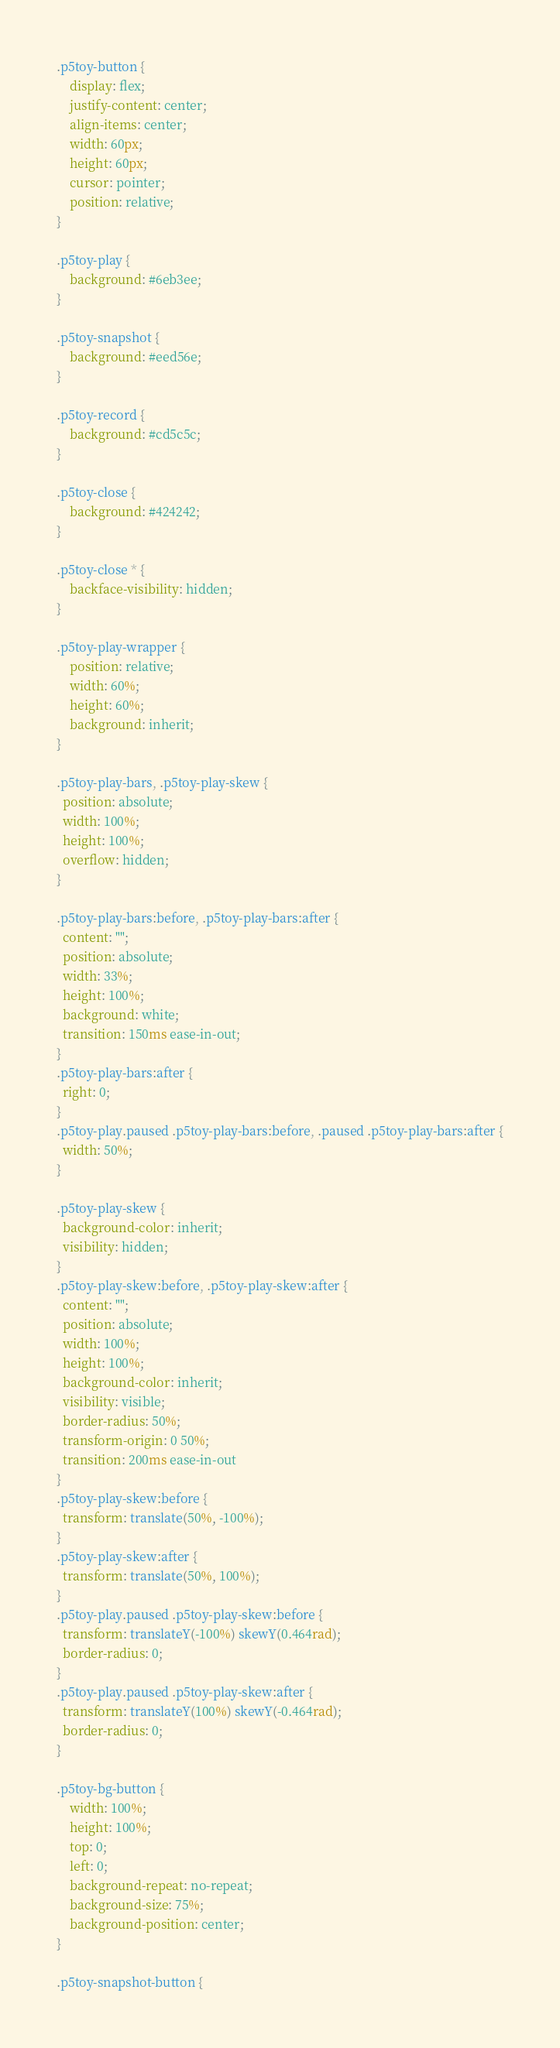Convert code to text. <code><loc_0><loc_0><loc_500><loc_500><_CSS_>
.p5toy-button {
	display: flex;
	justify-content: center;
	align-items: center;
	width: 60px;
	height: 60px;
	cursor: pointer;
	position: relative;
}

.p5toy-play {
	background: #6eb3ee;
}

.p5toy-snapshot {
	background: #eed56e;
}

.p5toy-record {
	background: #cd5c5c;
}

.p5toy-close {
	background: #424242;
}

.p5toy-close * {
	backface-visibility: hidden;
}

.p5toy-play-wrapper {
	position: relative;
	width: 60%;
	height: 60%;
	background: inherit;
}

.p5toy-play-bars, .p5toy-play-skew {
  position: absolute;
  width: 100%;
  height: 100%;
  overflow: hidden;
}

.p5toy-play-bars:before, .p5toy-play-bars:after {
  content: "";
  position: absolute;
  width: 33%;
  height: 100%;
  background: white;
  transition: 150ms ease-in-out;
}
.p5toy-play-bars:after {
  right: 0;
}
.p5toy-play.paused .p5toy-play-bars:before, .paused .p5toy-play-bars:after {
  width: 50%;
}

.p5toy-play-skew {
  background-color: inherit;
  visibility: hidden;
}
.p5toy-play-skew:before, .p5toy-play-skew:after {
  content: "";
  position: absolute;
  width: 100%;
  height: 100%;
  background-color: inherit;
  visibility: visible;
  border-radius: 50%;
  transform-origin: 0 50%;
  transition: 200ms ease-in-out
}
.p5toy-play-skew:before {
  transform: translate(50%, -100%);
}
.p5toy-play-skew:after {
  transform: translate(50%, 100%);
}
.p5toy-play.paused .p5toy-play-skew:before {
  transform: translateY(-100%) skewY(0.464rad);
  border-radius: 0;
}
.p5toy-play.paused .p5toy-play-skew:after {
  transform: translateY(100%) skewY(-0.464rad);  
  border-radius: 0;
}

.p5toy-bg-button {
    width: 100%;
    height: 100%;
    top: 0;
    left: 0;
    background-repeat: no-repeat;
    background-size: 75%;
    background-position: center;
}

.p5toy-snapshot-button {</code> 